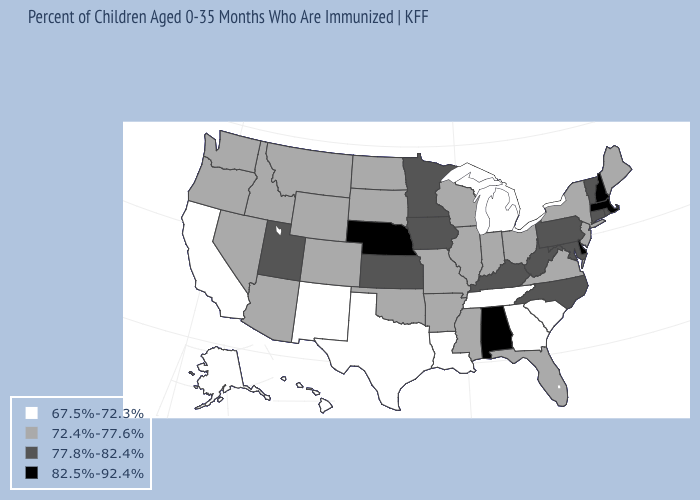Name the states that have a value in the range 67.5%-72.3%?
Answer briefly. Alaska, California, Georgia, Hawaii, Louisiana, Michigan, New Mexico, South Carolina, Tennessee, Texas. Does New Hampshire have a higher value than Arkansas?
Write a very short answer. Yes. What is the value of West Virginia?
Be succinct. 77.8%-82.4%. Does Utah have the lowest value in the West?
Concise answer only. No. What is the highest value in states that border Michigan?
Concise answer only. 72.4%-77.6%. Name the states that have a value in the range 72.4%-77.6%?
Quick response, please. Arizona, Arkansas, Colorado, Florida, Idaho, Illinois, Indiana, Maine, Mississippi, Missouri, Montana, Nevada, New Jersey, New York, North Dakota, Ohio, Oklahoma, Oregon, South Dakota, Virginia, Washington, Wisconsin, Wyoming. Does Alabama have the highest value in the USA?
Give a very brief answer. Yes. Among the states that border North Carolina , does Virginia have the highest value?
Concise answer only. Yes. Among the states that border Washington , which have the lowest value?
Quick response, please. Idaho, Oregon. What is the highest value in states that border Rhode Island?
Short answer required. 82.5%-92.4%. Does Ohio have a higher value than Oregon?
Give a very brief answer. No. Among the states that border Utah , which have the highest value?
Short answer required. Arizona, Colorado, Idaho, Nevada, Wyoming. Among the states that border New Jersey , does New York have the lowest value?
Write a very short answer. Yes. Does Alabama have the highest value in the USA?
Quick response, please. Yes. Does Connecticut have the highest value in the Northeast?
Write a very short answer. No. 